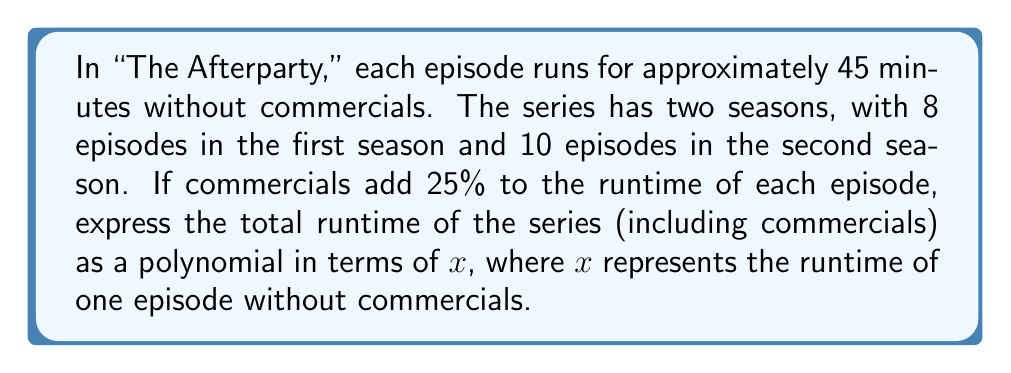Solve this math problem. Let's approach this step-by-step:

1) First, let's calculate the total number of episodes:
   Season 1: 8 episodes
   Season 2: 10 episodes
   Total: 8 + 10 = 18 episodes

2) Now, let x represent the runtime of one episode without commercials (which is 45 minutes).

3) The runtime of all episodes without commercials can be represented as:
   $$ 18x $$

4) Commercials add 25% to the runtime. This means we need to multiply the runtime by 1.25:
   $$ 18x \cdot 1.25 $$

5) Simplifying this expression:
   $$ 18x \cdot 1.25 = 22.5x $$

Therefore, the total runtime of the series including commercials can be expressed as the polynomial $22.5x$, where x is the runtime of one episode without commercials.

To verify:
If we substitute x = 45 minutes:
$$ 22.5 \cdot 45 = 1012.5 \text{ minutes} $$
Which is equivalent to 16 hours and 52.5 minutes for the entire series with commercials.
Answer: $22.5x$, where x is the runtime of one episode without commercials 